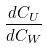Convert formula to latex. <formula><loc_0><loc_0><loc_500><loc_500>\frac { d C _ { U } } { d C _ { W } }</formula> 